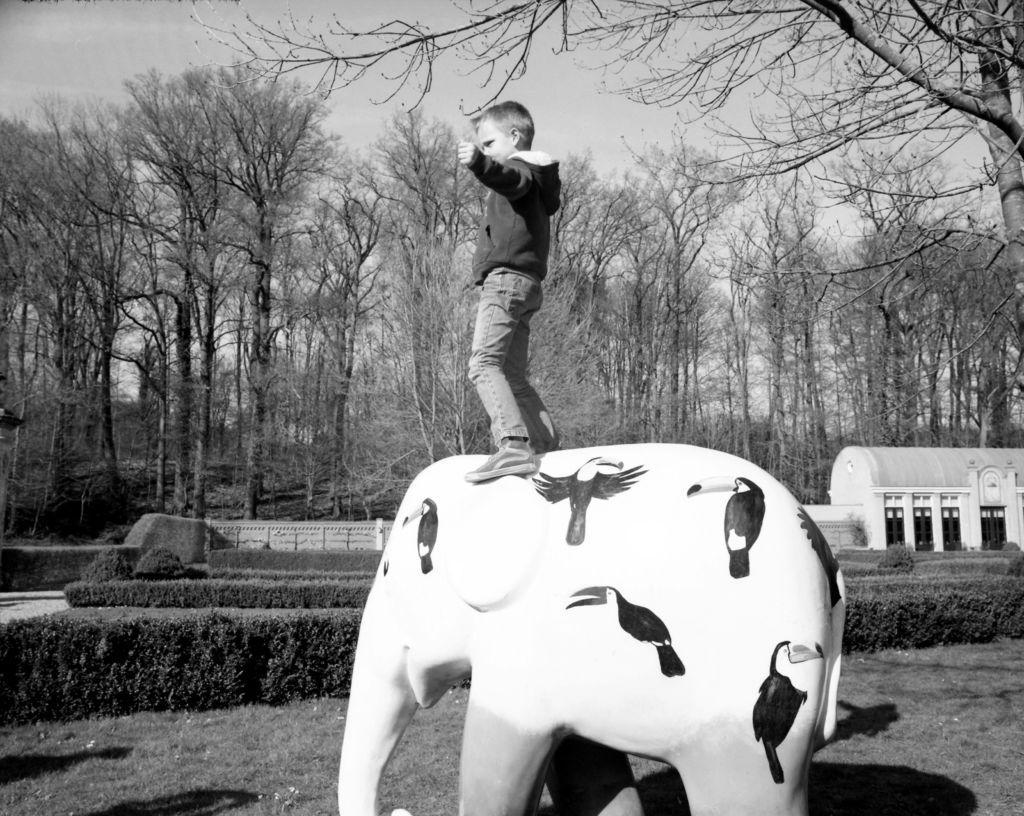Describe this image in one or two sentences. In this picture there is a boy standing on the statue of the elephant. At the back there is a building and there are trees. At the top there is sky. At the bottom there is grass. 